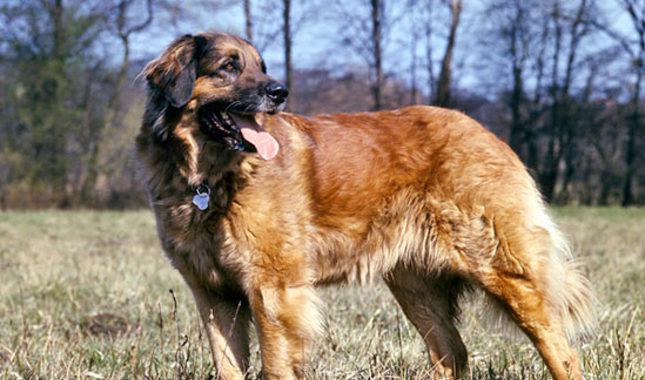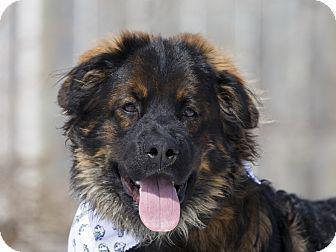The first image is the image on the left, the second image is the image on the right. For the images shown, is this caption "The sky can be seen behind the dog in the image on the left." true? Answer yes or no. Yes. 